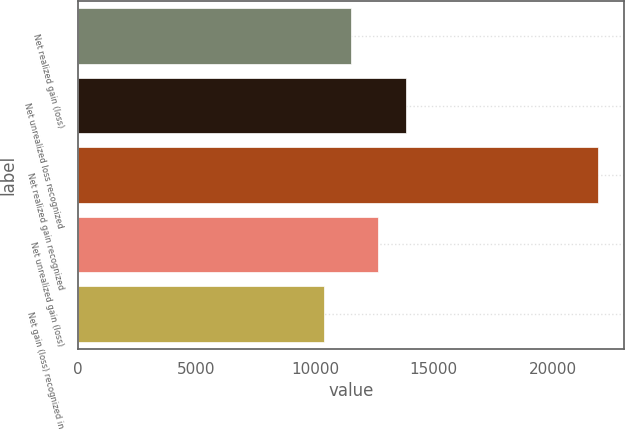<chart> <loc_0><loc_0><loc_500><loc_500><bar_chart><fcel>Net realized gain (loss)<fcel>Net unrealized loss recognized<fcel>Net realized gain recognized<fcel>Net unrealized gain (loss)<fcel>Net gain (loss) recognized in<nl><fcel>11509.8<fcel>13823.4<fcel>21921<fcel>12666.6<fcel>10353<nl></chart> 